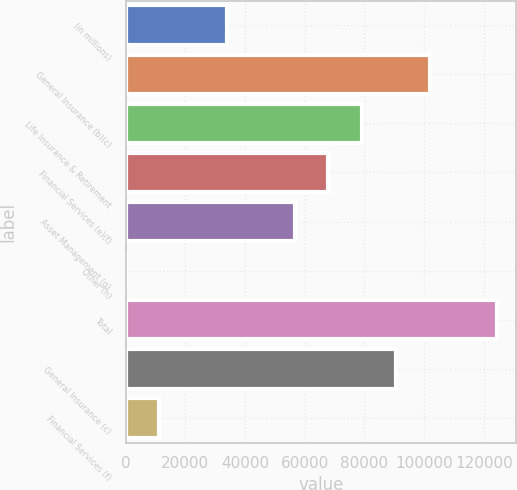Convert chart. <chart><loc_0><loc_0><loc_500><loc_500><bar_chart><fcel>(in millions)<fcel>General Insurance (b)(c)<fcel>Life Insurance & Retirement<fcel>Financial Services (e)(f)<fcel>Asset Management (g)<fcel>Other (h)<fcel>Total<fcel>General Insurance (c)<fcel>Financial Services (f)<nl><fcel>33958.9<fcel>101875<fcel>79236.1<fcel>67916.8<fcel>56597.5<fcel>1<fcel>124513<fcel>90555.4<fcel>11320.3<nl></chart> 